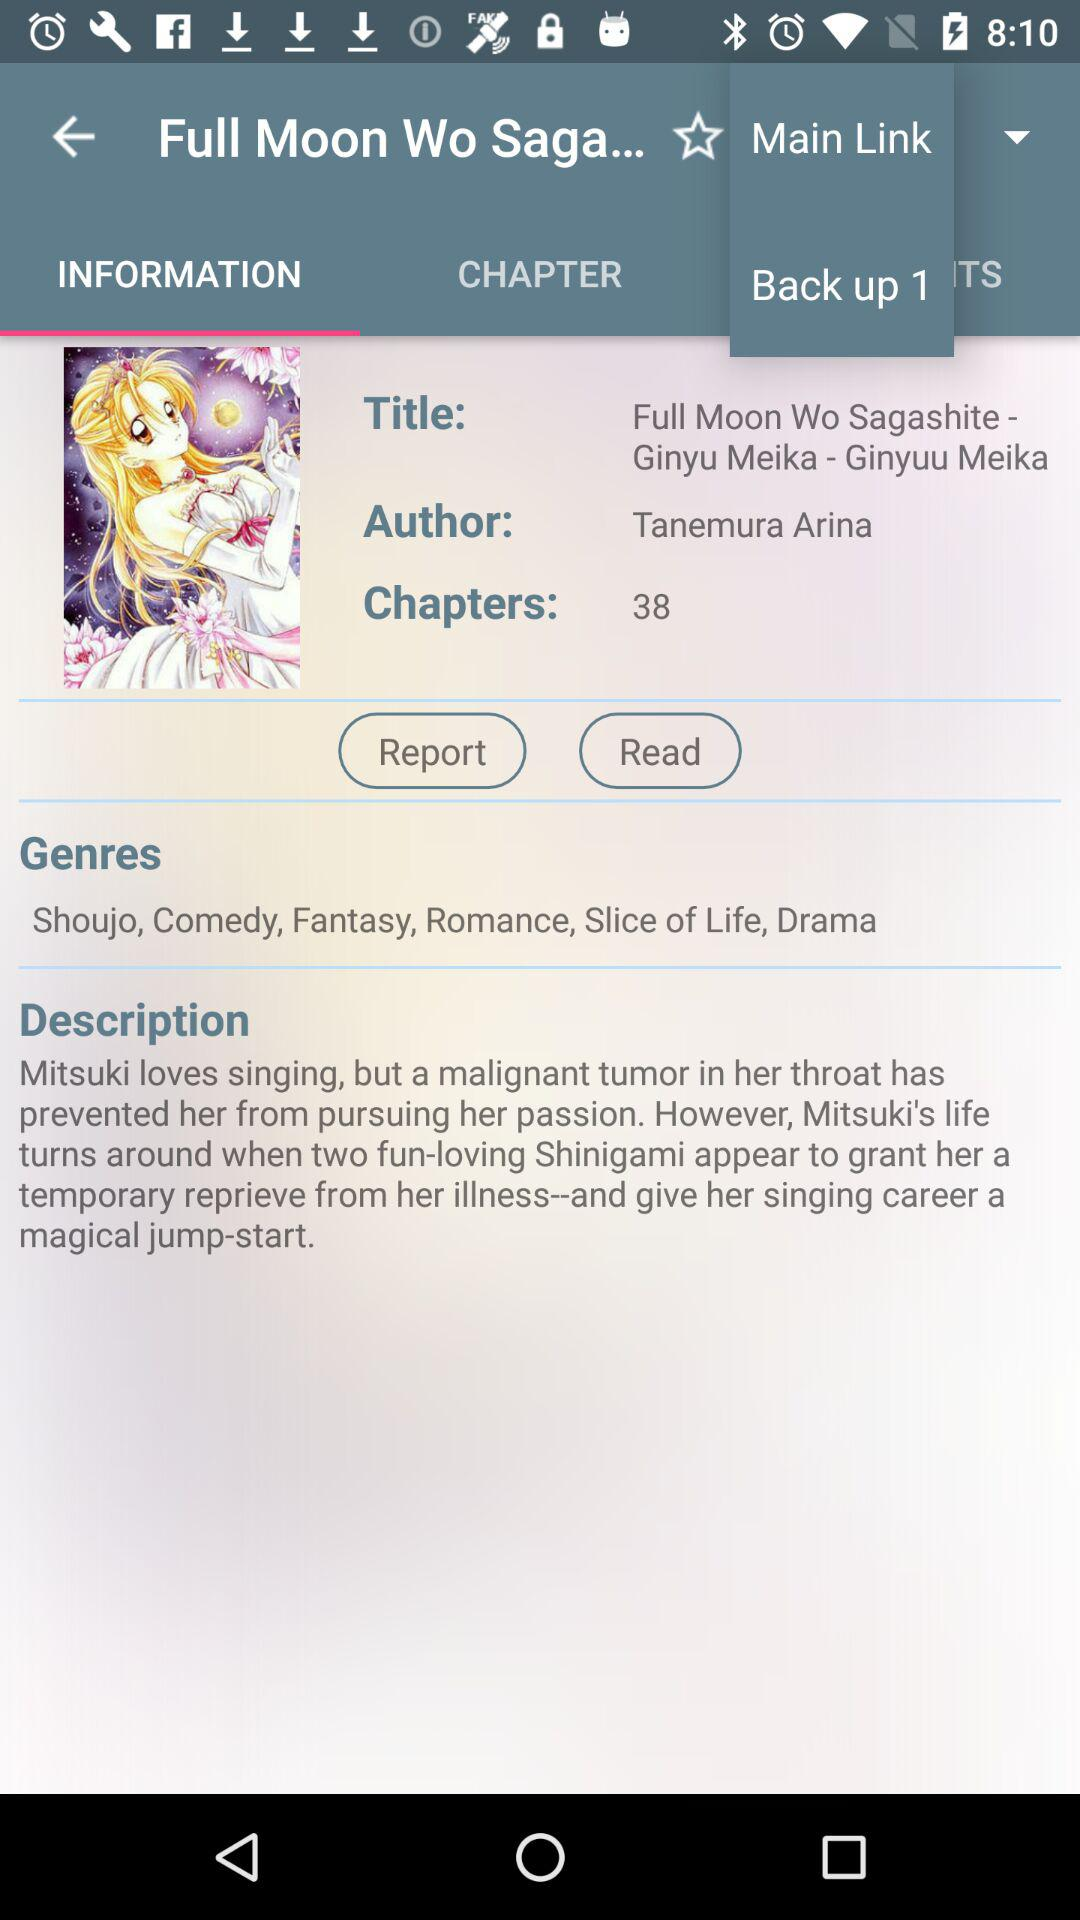Who is the author? The author is Tanemura Arina. 